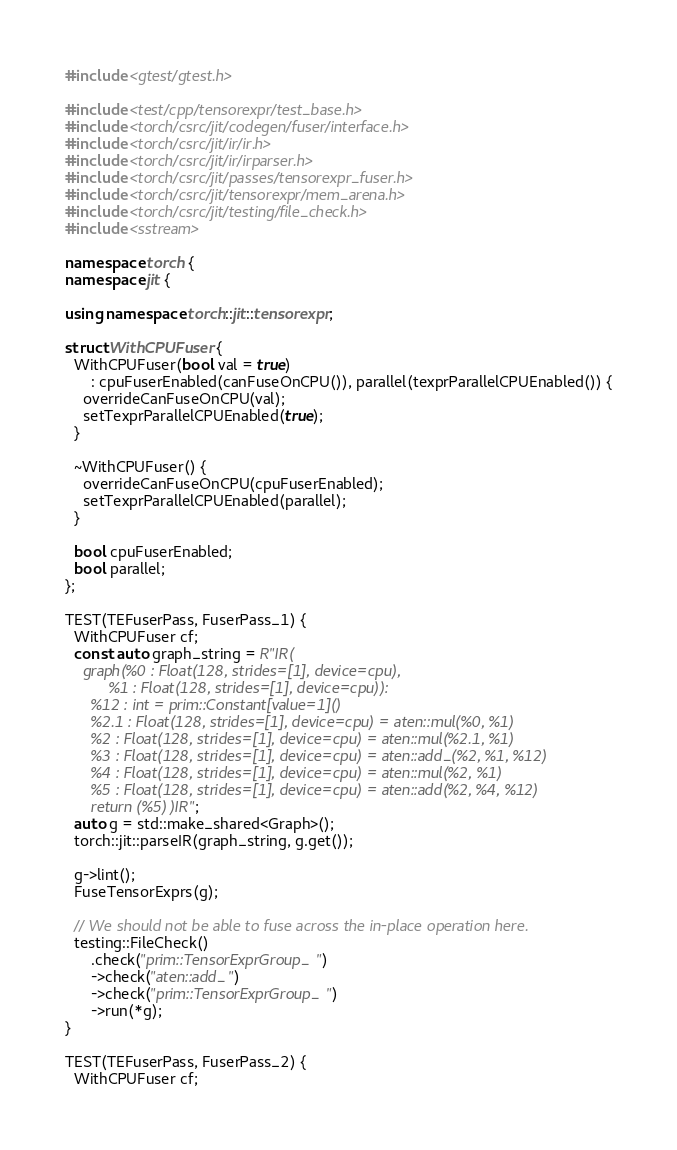Convert code to text. <code><loc_0><loc_0><loc_500><loc_500><_C++_>#include <gtest/gtest.h>

#include <test/cpp/tensorexpr/test_base.h>
#include <torch/csrc/jit/codegen/fuser/interface.h>
#include <torch/csrc/jit/ir/ir.h>
#include <torch/csrc/jit/ir/irparser.h>
#include <torch/csrc/jit/passes/tensorexpr_fuser.h>
#include <torch/csrc/jit/tensorexpr/mem_arena.h>
#include <torch/csrc/jit/testing/file_check.h>
#include <sstream>

namespace torch {
namespace jit {

using namespace torch::jit::tensorexpr;

struct WithCPUFuser {
  WithCPUFuser(bool val = true)
      : cpuFuserEnabled(canFuseOnCPU()), parallel(texprParallelCPUEnabled()) {
    overrideCanFuseOnCPU(val);
    setTexprParallelCPUEnabled(true);
  }

  ~WithCPUFuser() {
    overrideCanFuseOnCPU(cpuFuserEnabled);
    setTexprParallelCPUEnabled(parallel);
  }

  bool cpuFuserEnabled;
  bool parallel;
};

TEST(TEFuserPass, FuserPass_1) {
  WithCPUFuser cf;
  const auto graph_string = R"IR(
    graph(%0 : Float(128, strides=[1], device=cpu),
          %1 : Float(128, strides=[1], device=cpu)):
      %12 : int = prim::Constant[value=1]()
      %2.1 : Float(128, strides=[1], device=cpu) = aten::mul(%0, %1)
      %2 : Float(128, strides=[1], device=cpu) = aten::mul(%2.1, %1)
      %3 : Float(128, strides=[1], device=cpu) = aten::add_(%2, %1, %12)
      %4 : Float(128, strides=[1], device=cpu) = aten::mul(%2, %1)
      %5 : Float(128, strides=[1], device=cpu) = aten::add(%2, %4, %12)
      return (%5))IR";
  auto g = std::make_shared<Graph>();
  torch::jit::parseIR(graph_string, g.get());

  g->lint();
  FuseTensorExprs(g);

  // We should not be able to fuse across the in-place operation here.
  testing::FileCheck()
      .check("prim::TensorExprGroup_")
      ->check("aten::add_")
      ->check("prim::TensorExprGroup_")
      ->run(*g);
}

TEST(TEFuserPass, FuserPass_2) {
  WithCPUFuser cf;</code> 